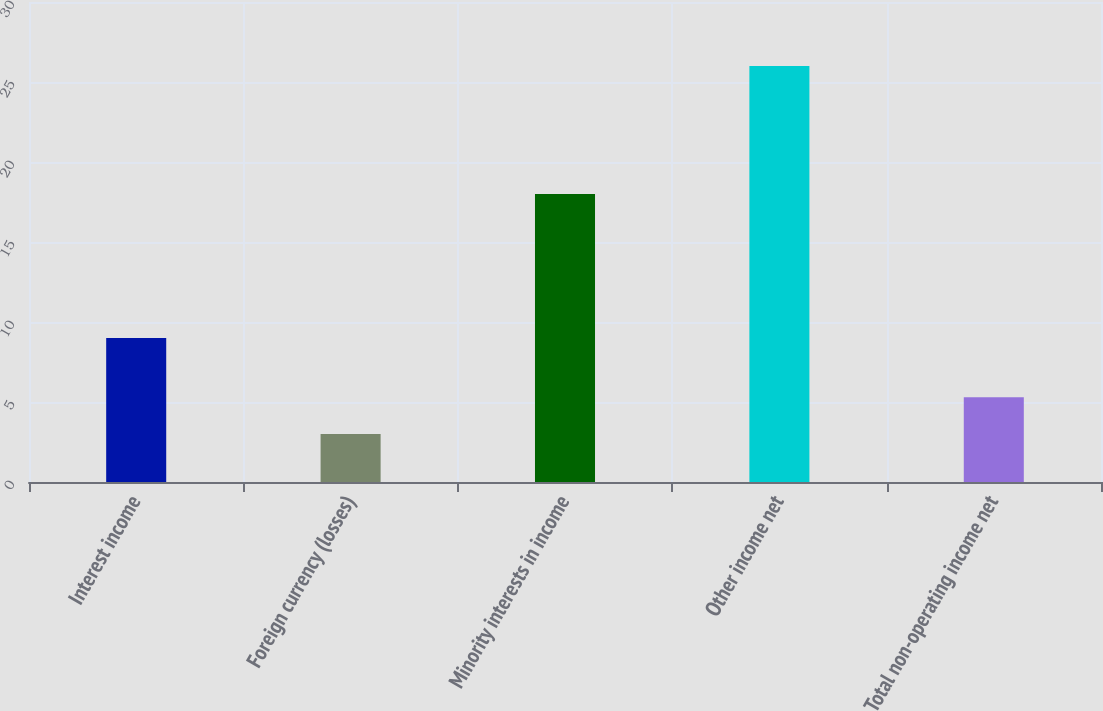Convert chart. <chart><loc_0><loc_0><loc_500><loc_500><bar_chart><fcel>Interest income<fcel>Foreign currency (losses)<fcel>Minority interests in income<fcel>Other income net<fcel>Total non-operating income net<nl><fcel>9<fcel>3<fcel>18<fcel>26<fcel>5.3<nl></chart> 